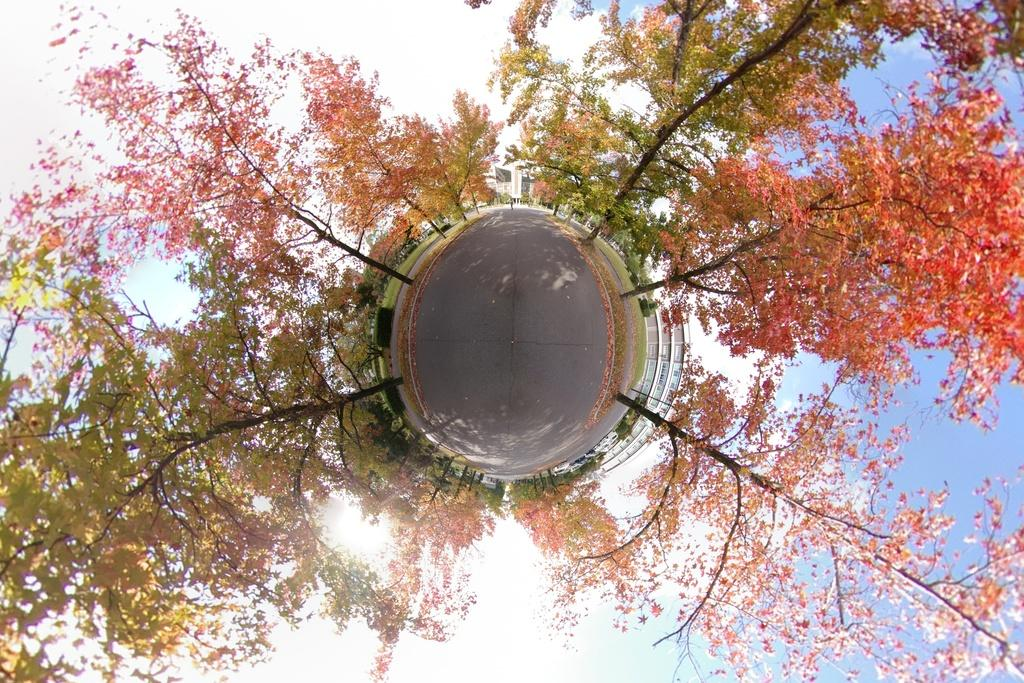What type of plant can be seen in the image? There is a tree with leaves in the image. What part of the natural environment is visible in the image? The sky is visible in the background of the image. What type of food is hanging from the tree in the image? There is no food hanging from the tree in the image; it is a tree with leaves. What type of gold object is visible in the image? There is no gold object present in the image. 